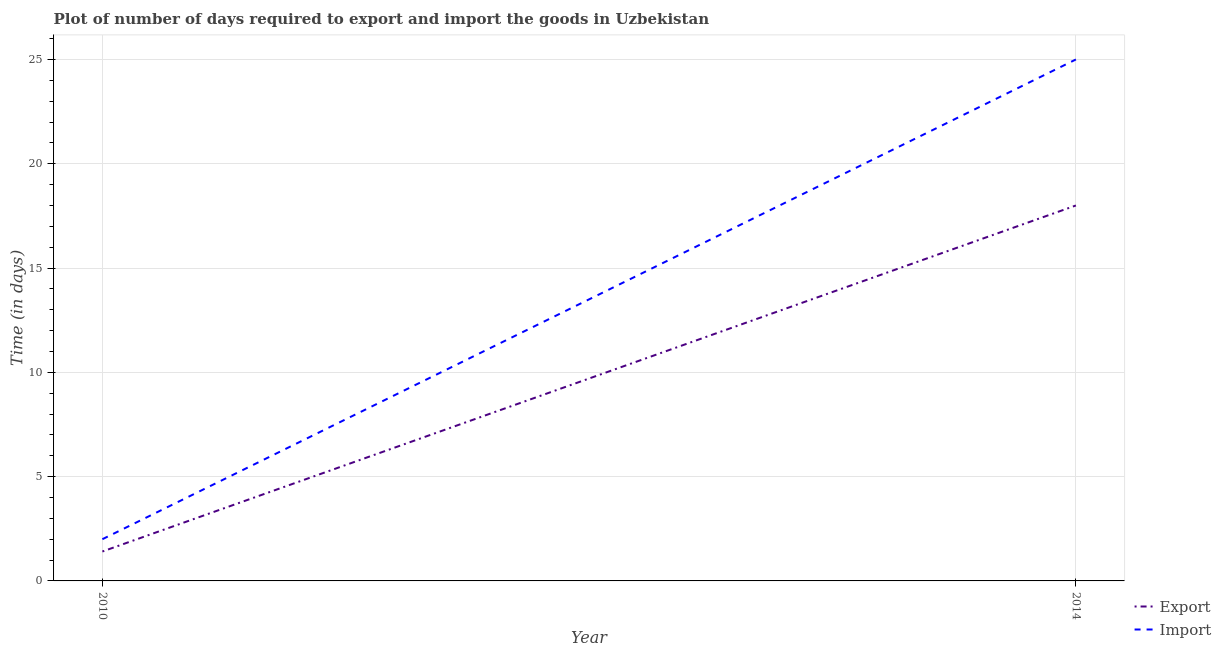Is the number of lines equal to the number of legend labels?
Your response must be concise. Yes. What is the time required to export in 2010?
Make the answer very short. 1.41. Across all years, what is the minimum time required to import?
Your answer should be compact. 2. What is the total time required to import in the graph?
Make the answer very short. 27. What is the difference between the time required to import in 2010 and that in 2014?
Offer a very short reply. -23. What is the difference between the time required to export in 2014 and the time required to import in 2010?
Offer a terse response. 16. In the year 2010, what is the difference between the time required to import and time required to export?
Offer a terse response. 0.59. What is the ratio of the time required to export in 2010 to that in 2014?
Your response must be concise. 0.08. Does the time required to import monotonically increase over the years?
Your answer should be compact. Yes. Is the time required to export strictly less than the time required to import over the years?
Keep it short and to the point. Yes. How many lines are there?
Provide a succinct answer. 2. How many years are there in the graph?
Ensure brevity in your answer.  2. What is the difference between two consecutive major ticks on the Y-axis?
Give a very brief answer. 5. Are the values on the major ticks of Y-axis written in scientific E-notation?
Provide a succinct answer. No. Does the graph contain any zero values?
Make the answer very short. No. What is the title of the graph?
Ensure brevity in your answer.  Plot of number of days required to export and import the goods in Uzbekistan. Does "National Visitors" appear as one of the legend labels in the graph?
Offer a very short reply. No. What is the label or title of the X-axis?
Make the answer very short. Year. What is the label or title of the Y-axis?
Keep it short and to the point. Time (in days). What is the Time (in days) in Export in 2010?
Offer a terse response. 1.41. What is the Time (in days) in Export in 2014?
Make the answer very short. 18. What is the Time (in days) of Import in 2014?
Provide a short and direct response. 25. Across all years, what is the maximum Time (in days) in Export?
Provide a short and direct response. 18. Across all years, what is the maximum Time (in days) of Import?
Offer a very short reply. 25. Across all years, what is the minimum Time (in days) in Export?
Offer a terse response. 1.41. What is the total Time (in days) in Export in the graph?
Your answer should be compact. 19.41. What is the difference between the Time (in days) in Export in 2010 and that in 2014?
Your answer should be very brief. -16.59. What is the difference between the Time (in days) of Import in 2010 and that in 2014?
Offer a very short reply. -23. What is the difference between the Time (in days) in Export in 2010 and the Time (in days) in Import in 2014?
Give a very brief answer. -23.59. What is the average Time (in days) of Export per year?
Offer a very short reply. 9.71. What is the average Time (in days) of Import per year?
Your answer should be very brief. 13.5. In the year 2010, what is the difference between the Time (in days) in Export and Time (in days) in Import?
Provide a short and direct response. -0.59. What is the ratio of the Time (in days) in Export in 2010 to that in 2014?
Ensure brevity in your answer.  0.08. What is the ratio of the Time (in days) of Import in 2010 to that in 2014?
Your response must be concise. 0.08. What is the difference between the highest and the second highest Time (in days) in Export?
Give a very brief answer. 16.59. What is the difference between the highest and the second highest Time (in days) of Import?
Give a very brief answer. 23. What is the difference between the highest and the lowest Time (in days) in Export?
Offer a terse response. 16.59. What is the difference between the highest and the lowest Time (in days) in Import?
Provide a short and direct response. 23. 